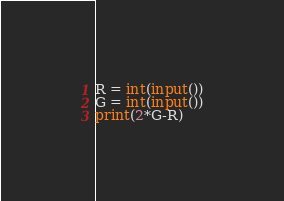<code> <loc_0><loc_0><loc_500><loc_500><_Python_>R = int(input())
G = int(input())
print(2*G-R)</code> 